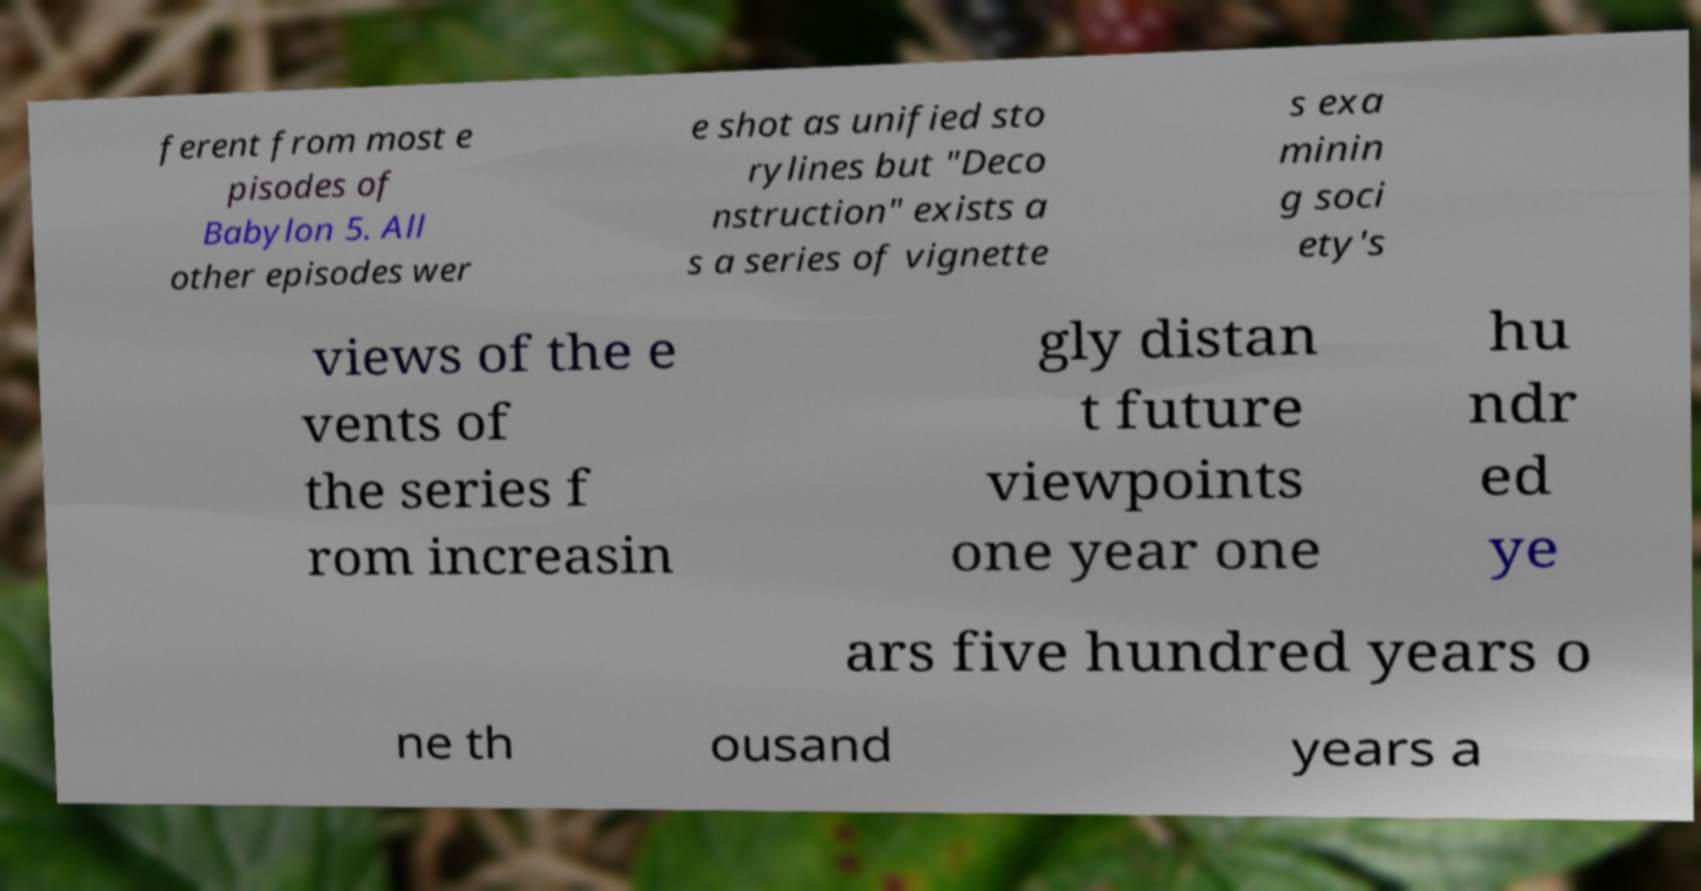Could you assist in decoding the text presented in this image and type it out clearly? ferent from most e pisodes of Babylon 5. All other episodes wer e shot as unified sto rylines but "Deco nstruction" exists a s a series of vignette s exa minin g soci ety's views of the e vents of the series f rom increasin gly distan t future viewpoints one year one hu ndr ed ye ars five hundred years o ne th ousand years a 